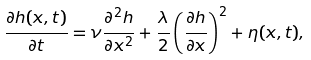<formula> <loc_0><loc_0><loc_500><loc_500>\frac { \partial h ( x , t ) } { \partial t } = \nu \frac { \partial ^ { 2 } h } { \partial x ^ { 2 } } + \frac { \lambda } { 2 } \left ( \frac { \partial h } { \partial x } \right ) ^ { 2 } + \eta ( x , t ) ,</formula> 